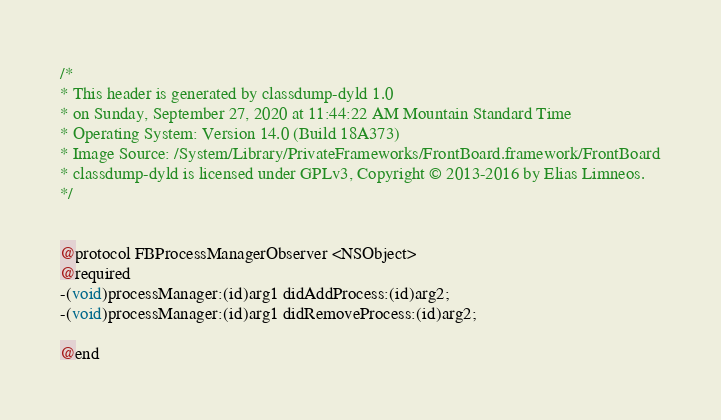Convert code to text. <code><loc_0><loc_0><loc_500><loc_500><_C_>/*
* This header is generated by classdump-dyld 1.0
* on Sunday, September 27, 2020 at 11:44:22 AM Mountain Standard Time
* Operating System: Version 14.0 (Build 18A373)
* Image Source: /System/Library/PrivateFrameworks/FrontBoard.framework/FrontBoard
* classdump-dyld is licensed under GPLv3, Copyright © 2013-2016 by Elias Limneos.
*/


@protocol FBProcessManagerObserver <NSObject>
@required
-(void)processManager:(id)arg1 didAddProcess:(id)arg2;
-(void)processManager:(id)arg1 didRemoveProcess:(id)arg2;

@end

</code> 